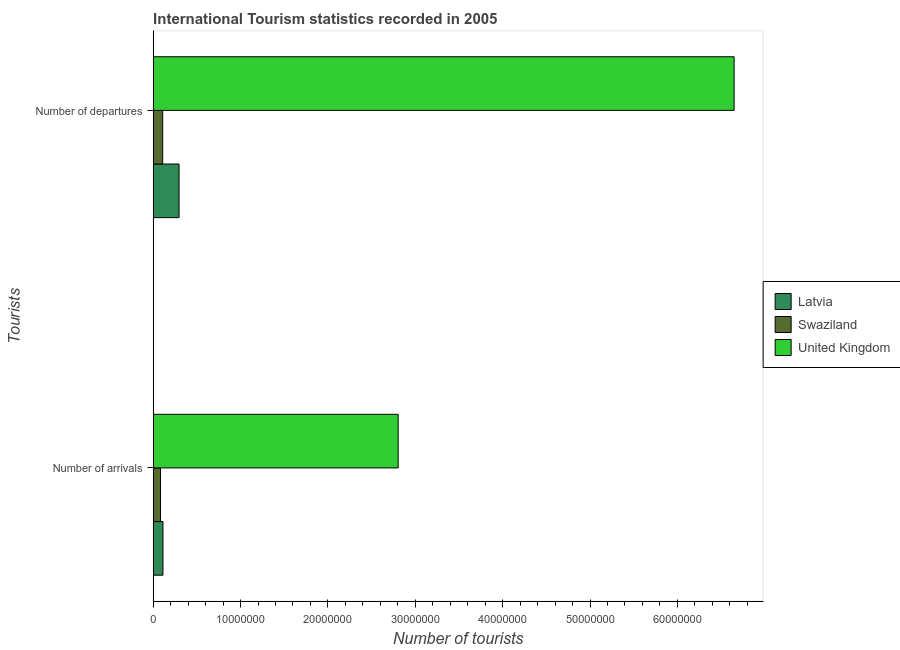How many groups of bars are there?
Ensure brevity in your answer.  2. Are the number of bars per tick equal to the number of legend labels?
Keep it short and to the point. Yes. Are the number of bars on each tick of the Y-axis equal?
Offer a terse response. Yes. What is the label of the 1st group of bars from the top?
Provide a short and direct response. Number of departures. What is the number of tourist arrivals in Latvia?
Your answer should be compact. 1.12e+06. Across all countries, what is the maximum number of tourist departures?
Provide a succinct answer. 6.65e+07. Across all countries, what is the minimum number of tourist departures?
Give a very brief answer. 1.08e+06. In which country was the number of tourist departures maximum?
Give a very brief answer. United Kingdom. In which country was the number of tourist arrivals minimum?
Offer a very short reply. Swaziland. What is the total number of tourist arrivals in the graph?
Keep it short and to the point. 3.00e+07. What is the difference between the number of tourist arrivals in Swaziland and that in United Kingdom?
Keep it short and to the point. -2.72e+07. What is the difference between the number of tourist departures in Swaziland and the number of tourist arrivals in United Kingdom?
Your answer should be compact. -2.70e+07. What is the average number of tourist arrivals per country?
Provide a succinct answer. 1.00e+07. What is the difference between the number of tourist arrivals and number of tourist departures in Latvia?
Your response must be concise. -1.84e+06. What is the ratio of the number of tourist departures in Latvia to that in Swaziland?
Offer a terse response. 2.73. Is the number of tourist departures in Latvia less than that in United Kingdom?
Your answer should be compact. Yes. What does the 3rd bar from the top in Number of arrivals represents?
Ensure brevity in your answer.  Latvia. What does the 2nd bar from the bottom in Number of arrivals represents?
Your response must be concise. Swaziland. How many bars are there?
Provide a short and direct response. 6. How many countries are there in the graph?
Your answer should be compact. 3. Are the values on the major ticks of X-axis written in scientific E-notation?
Provide a succinct answer. No. Does the graph contain any zero values?
Offer a terse response. No. Does the graph contain grids?
Your response must be concise. No. How are the legend labels stacked?
Offer a terse response. Vertical. What is the title of the graph?
Ensure brevity in your answer.  International Tourism statistics recorded in 2005. What is the label or title of the X-axis?
Provide a succinct answer. Number of tourists. What is the label or title of the Y-axis?
Your answer should be very brief. Tourists. What is the Number of tourists in Latvia in Number of arrivals?
Ensure brevity in your answer.  1.12e+06. What is the Number of tourists in Swaziland in Number of arrivals?
Provide a succinct answer. 8.37e+05. What is the Number of tourists in United Kingdom in Number of arrivals?
Your response must be concise. 2.80e+07. What is the Number of tourists in Latvia in Number of departures?
Your answer should be compact. 2.96e+06. What is the Number of tourists of Swaziland in Number of departures?
Offer a terse response. 1.08e+06. What is the Number of tourists in United Kingdom in Number of departures?
Provide a short and direct response. 6.65e+07. Across all Tourists, what is the maximum Number of tourists of Latvia?
Offer a terse response. 2.96e+06. Across all Tourists, what is the maximum Number of tourists in Swaziland?
Your answer should be compact. 1.08e+06. Across all Tourists, what is the maximum Number of tourists in United Kingdom?
Your answer should be very brief. 6.65e+07. Across all Tourists, what is the minimum Number of tourists in Latvia?
Your answer should be compact. 1.12e+06. Across all Tourists, what is the minimum Number of tourists in Swaziland?
Offer a very short reply. 8.37e+05. Across all Tourists, what is the minimum Number of tourists of United Kingdom?
Your response must be concise. 2.80e+07. What is the total Number of tourists in Latvia in the graph?
Your answer should be very brief. 4.08e+06. What is the total Number of tourists of Swaziland in the graph?
Offer a very short reply. 1.92e+06. What is the total Number of tourists in United Kingdom in the graph?
Offer a terse response. 9.45e+07. What is the difference between the Number of tourists of Latvia in Number of arrivals and that in Number of departures?
Ensure brevity in your answer.  -1.84e+06. What is the difference between the Number of tourists of Swaziland in Number of arrivals and that in Number of departures?
Provide a succinct answer. -2.45e+05. What is the difference between the Number of tourists in United Kingdom in Number of arrivals and that in Number of departures?
Provide a succinct answer. -3.85e+07. What is the difference between the Number of tourists of Latvia in Number of arrivals and the Number of tourists of Swaziland in Number of departures?
Keep it short and to the point. 3.40e+04. What is the difference between the Number of tourists in Latvia in Number of arrivals and the Number of tourists in United Kingdom in Number of departures?
Keep it short and to the point. -6.54e+07. What is the difference between the Number of tourists of Swaziland in Number of arrivals and the Number of tourists of United Kingdom in Number of departures?
Your answer should be very brief. -6.57e+07. What is the average Number of tourists of Latvia per Tourists?
Keep it short and to the point. 2.04e+06. What is the average Number of tourists in Swaziland per Tourists?
Your response must be concise. 9.60e+05. What is the average Number of tourists of United Kingdom per Tourists?
Your response must be concise. 4.73e+07. What is the difference between the Number of tourists of Latvia and Number of tourists of Swaziland in Number of arrivals?
Make the answer very short. 2.79e+05. What is the difference between the Number of tourists of Latvia and Number of tourists of United Kingdom in Number of arrivals?
Your response must be concise. -2.69e+07. What is the difference between the Number of tourists of Swaziland and Number of tourists of United Kingdom in Number of arrivals?
Your answer should be very brief. -2.72e+07. What is the difference between the Number of tourists of Latvia and Number of tourists of Swaziland in Number of departures?
Your answer should be very brief. 1.88e+06. What is the difference between the Number of tourists in Latvia and Number of tourists in United Kingdom in Number of departures?
Give a very brief answer. -6.35e+07. What is the difference between the Number of tourists in Swaziland and Number of tourists in United Kingdom in Number of departures?
Offer a very short reply. -6.54e+07. What is the ratio of the Number of tourists of Latvia in Number of arrivals to that in Number of departures?
Make the answer very short. 0.38. What is the ratio of the Number of tourists in Swaziland in Number of arrivals to that in Number of departures?
Offer a very short reply. 0.77. What is the ratio of the Number of tourists in United Kingdom in Number of arrivals to that in Number of departures?
Ensure brevity in your answer.  0.42. What is the difference between the highest and the second highest Number of tourists of Latvia?
Ensure brevity in your answer.  1.84e+06. What is the difference between the highest and the second highest Number of tourists of Swaziland?
Provide a succinct answer. 2.45e+05. What is the difference between the highest and the second highest Number of tourists of United Kingdom?
Ensure brevity in your answer.  3.85e+07. What is the difference between the highest and the lowest Number of tourists of Latvia?
Your answer should be compact. 1.84e+06. What is the difference between the highest and the lowest Number of tourists of Swaziland?
Offer a very short reply. 2.45e+05. What is the difference between the highest and the lowest Number of tourists in United Kingdom?
Make the answer very short. 3.85e+07. 